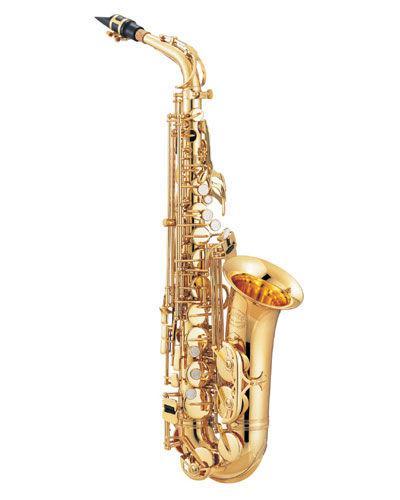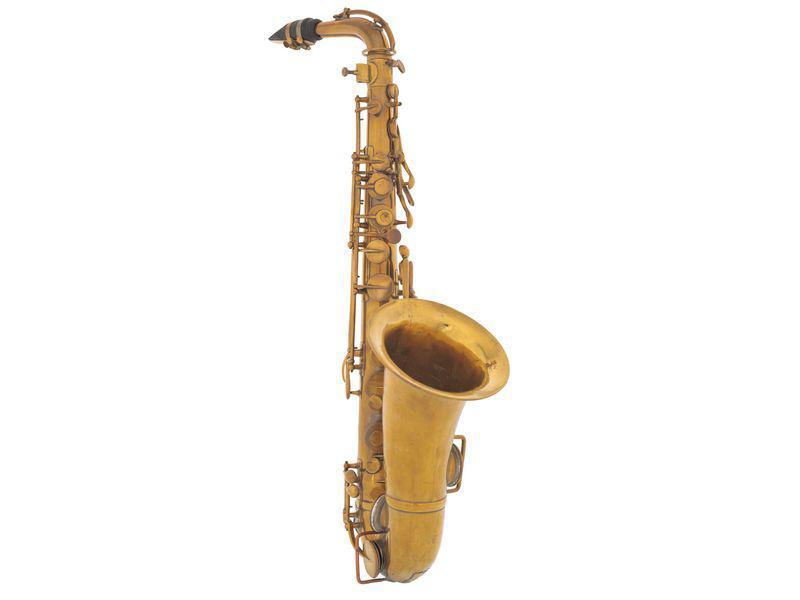The first image is the image on the left, the second image is the image on the right. Considering the images on both sides, is "The instrument in the image on the right is badly tarnished." valid? Answer yes or no. Yes. 